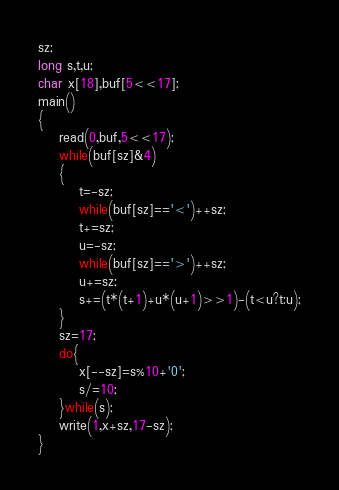Convert code to text. <code><loc_0><loc_0><loc_500><loc_500><_C_>sz;
long s,t,u;
char x[18],buf[5<<17];
main()
{
	read(0,buf,5<<17);
	while(buf[sz]&4)
	{
		t=-sz;
		while(buf[sz]=='<')++sz;
		t+=sz;
		u=-sz;
		while(buf[sz]=='>')++sz;
		u+=sz;
		s+=(t*(t+1)+u*(u+1)>>1)-(t<u?t:u);
	}
	sz=17;
	do{
		x[--sz]=s%10+'0';
		s/=10;
	}while(s);
	write(1,x+sz,17-sz);
}</code> 